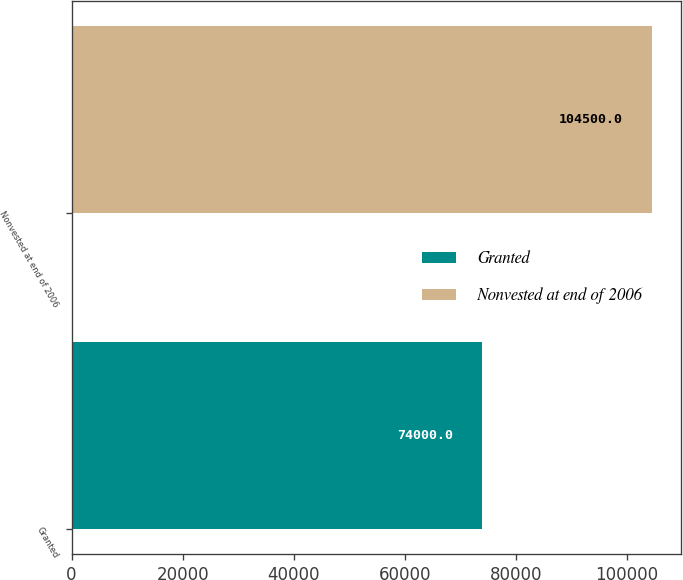Convert chart. <chart><loc_0><loc_0><loc_500><loc_500><bar_chart><fcel>Granted<fcel>Nonvested at end of 2006<nl><fcel>74000<fcel>104500<nl></chart> 